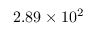Convert formula to latex. <formula><loc_0><loc_0><loc_500><loc_500>2 . 8 9 \times 1 0 ^ { 2 }</formula> 